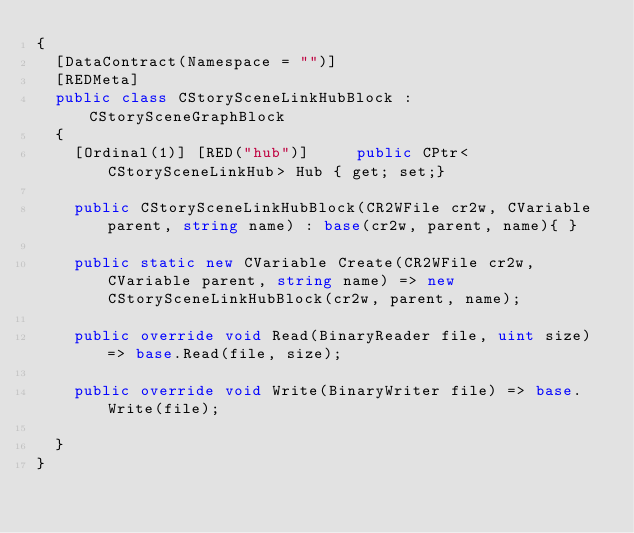<code> <loc_0><loc_0><loc_500><loc_500><_C#_>{
	[DataContract(Namespace = "")]
	[REDMeta]
	public class CStorySceneLinkHubBlock : CStorySceneGraphBlock
	{
		[Ordinal(1)] [RED("hub")] 		public CPtr<CStorySceneLinkHub> Hub { get; set;}

		public CStorySceneLinkHubBlock(CR2WFile cr2w, CVariable parent, string name) : base(cr2w, parent, name){ }

		public static new CVariable Create(CR2WFile cr2w, CVariable parent, string name) => new CStorySceneLinkHubBlock(cr2w, parent, name);

		public override void Read(BinaryReader file, uint size) => base.Read(file, size);

		public override void Write(BinaryWriter file) => base.Write(file);

	}
}</code> 